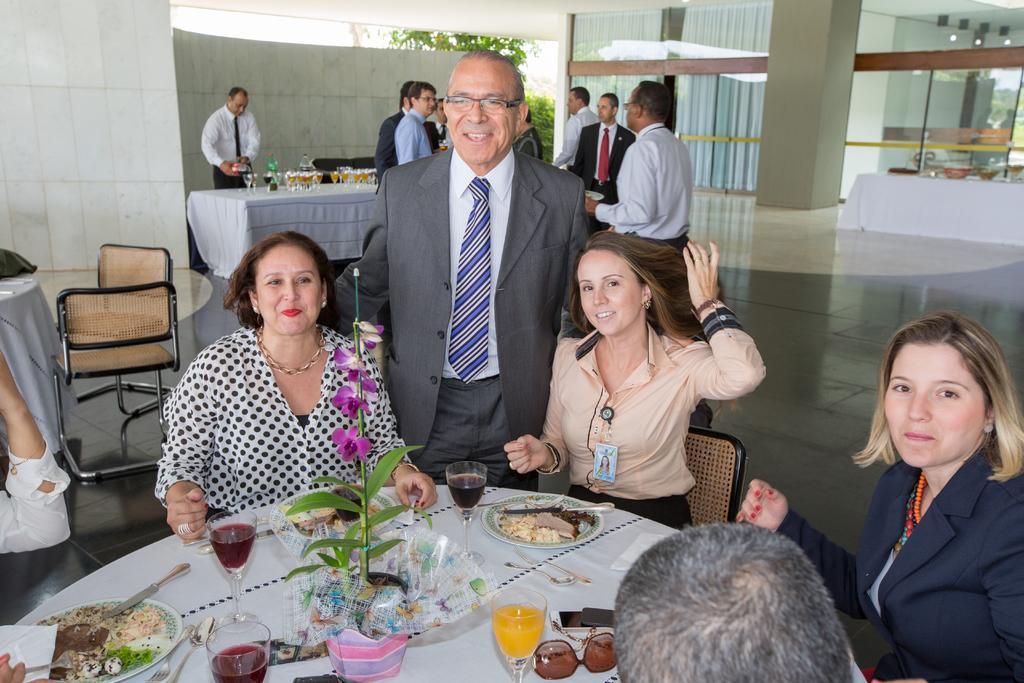Describe this image in one or two sentences. As we can see in the image there are few people and standing and there are tables over here. On table there is a glass, goggles, plate and fork and there is white color tiles over here. 